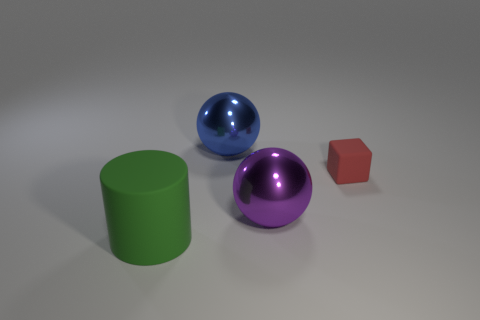Add 3 tiny brown metallic things. How many objects exist? 7 Subtract all cylinders. How many objects are left? 3 Subtract all large purple metal objects. Subtract all large cyan metallic objects. How many objects are left? 3 Add 4 big green rubber things. How many big green rubber things are left? 5 Add 1 large balls. How many large balls exist? 3 Subtract all blue spheres. How many spheres are left? 1 Subtract 0 brown cylinders. How many objects are left? 4 Subtract 1 balls. How many balls are left? 1 Subtract all gray balls. Subtract all cyan cylinders. How many balls are left? 2 Subtract all brown cubes. How many gray balls are left? 0 